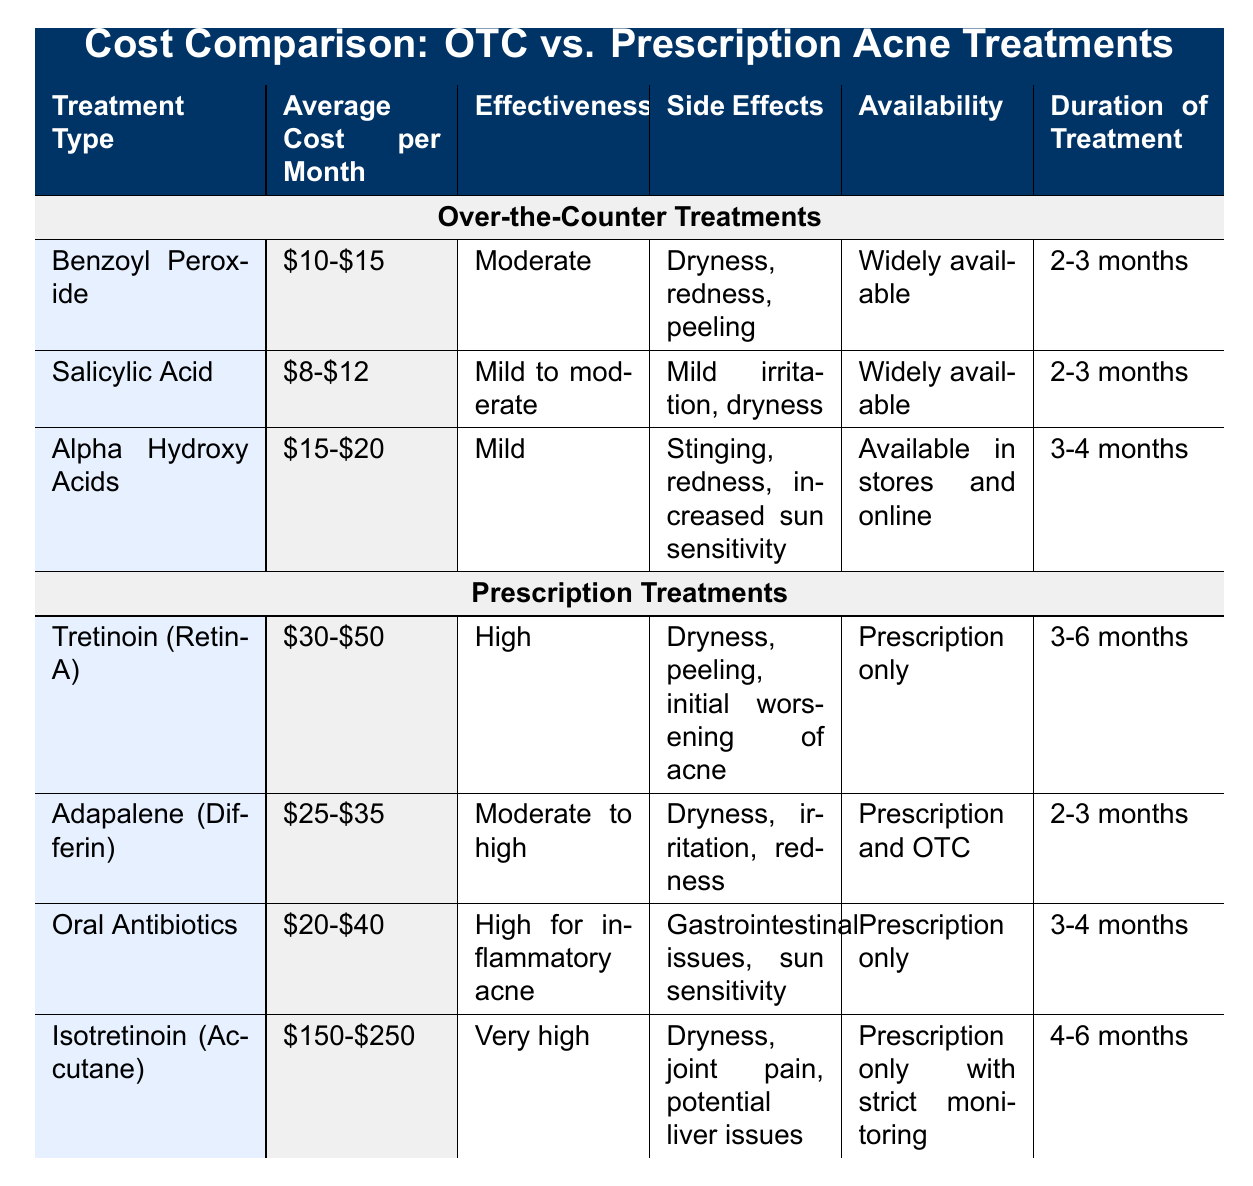What is the average cost per month for salicylic acid treatments? The table lists the average cost per month for salicylic acid as $8-$12. Thus, the average can be computed as (8 + 12) / 2 which equals $10.
Answer: $10 Which treatment type has the highest effectiveness according to the table? The table shows that Isotretinoin (Accutane) has the description of "Very high" effectiveness, which is higher than any other listed treatments.
Answer: Isotretinoin (Accutane) Do all prescription treatments have a higher average cost per month than over-the-counter treatments? By comparing the costs in the table, the lowest prescription treatment (Adapalene at $25-$35) is still higher than the highest over-the-counter treatment (Alpha Hydroxy Acids at $15-$20). Therefore, yes, all prescription treatments have a higher cost.
Answer: Yes What is the total duration of treatment if a patient uses both Benzoyl Peroxide and Salicylic Acid consecutively? Benzoyl Peroxide requires 2-3 months, and Salicylic Acid also requires 2-3 months. For the total, we calculate 2-3 months + 2-3 months, which gives us a range of 4-6 months overall.
Answer: 4-6 months Is dryness a side effect of at least one over-the-counter treatment? The side effects of Benzoyl Peroxide include dryness, and thus this statement is true.
Answer: Yes How much more expensive is Isotretinoin compared to Benzoyl Peroxide on average? The average cost for Isotretinoin is ($150 + $250) / 2 = $200, and for Benzoyl Peroxide it is ($10 + $15) / 2 = $12.5. Thus, $200 - $12.5 = $187.5 more expensive.
Answer: $187.5 What is the average duration of treatment for the over-the-counter options? The average durations for over-the-counter treatments are 2.5 months for Benzoyl Peroxide, 2.5 months for Salicylic Acid, and 3.5 months for Alpha Hydroxy Acids. Averaging these: (2.5 + 2.5 + 3.5) / 3 = 2.83 months.
Answer: 2.83 months Are there any prescription treatments that can also be found over-the-counter? Yes, Adapalene (Differin) is listed as both prescription and over-the-counter, confirming that at least one prescription treatment is available over-the-counter.
Answer: Yes 